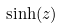<formula> <loc_0><loc_0><loc_500><loc_500>\sinh ( z )</formula> 